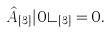Convert formula to latex. <formula><loc_0><loc_0><loc_500><loc_500>\hat { A } _ { [ 3 ] } | 0 \rangle _ { [ 3 ] } = 0 .</formula> 